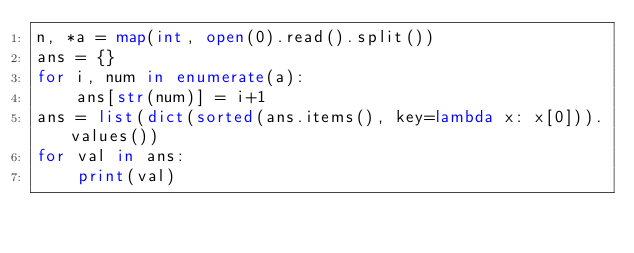Convert code to text. <code><loc_0><loc_0><loc_500><loc_500><_Python_>n, *a = map(int, open(0).read().split())
ans = {}
for i, num in enumerate(a):
    ans[str(num)] = i+1
ans = list(dict(sorted(ans.items(), key=lambda x: x[0])).values())
for val in ans:
    print(val)</code> 